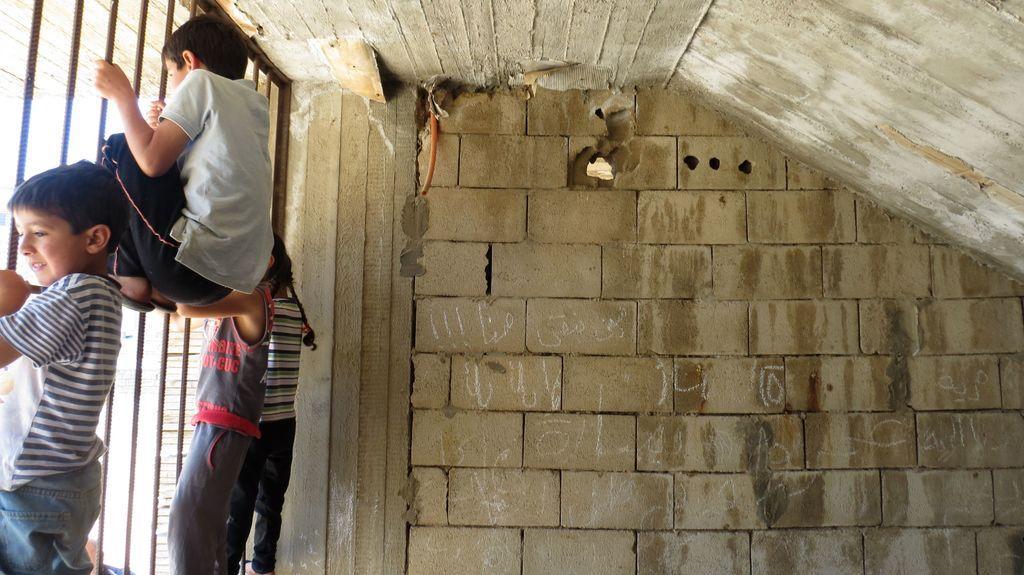Please provide a concise description of this image. On the left side of the picture there are kids hanging to the grill. In the center of the picture there is a brick wall. On the top it is ceiling with cement. On the wall there is text. 